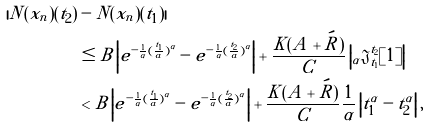<formula> <loc_0><loc_0><loc_500><loc_500>| N ( x _ { n } ) ( t _ { 2 } ) & - N ( x _ { n } ) ( t _ { 1 } ) | \\ & \leq B \left | e ^ { - \frac { 1 } { \alpha } ( \frac { t _ { 1 } } { a } ) ^ { \alpha } } - e ^ { - \frac { 1 } { \alpha } ( \frac { t _ { 2 } } { a } ) ^ { \alpha } } \right | + \frac { K ( A + \acute { R } ) } { C } \left | { _ { \alpha } \mathfrak { J } } _ { t _ { 1 } } ^ { t _ { 2 } } [ 1 ] \right | \\ & < B \left | e ^ { - \frac { 1 } { \alpha } ( \frac { t _ { 1 } } { a } ) ^ { \alpha } } - e ^ { - \frac { 1 } { \alpha } ( \frac { t _ { 2 } } { a } ) ^ { \alpha } } \right | + \frac { K ( A + \acute { R } ) } { C } \frac { 1 } { \alpha } \left | t _ { 1 } ^ { \alpha } - t _ { 2 } ^ { \alpha } \right | ,</formula> 